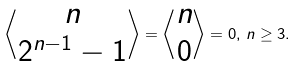<formula> <loc_0><loc_0><loc_500><loc_500>\left \langle \begin{matrix} n \\ 2 ^ { n - 1 } - 1 \end{matrix} \right \rangle = \left \langle \begin{matrix} n \\ 0 \end{matrix} \right \rangle = 0 , \, n \geq 3 .</formula> 